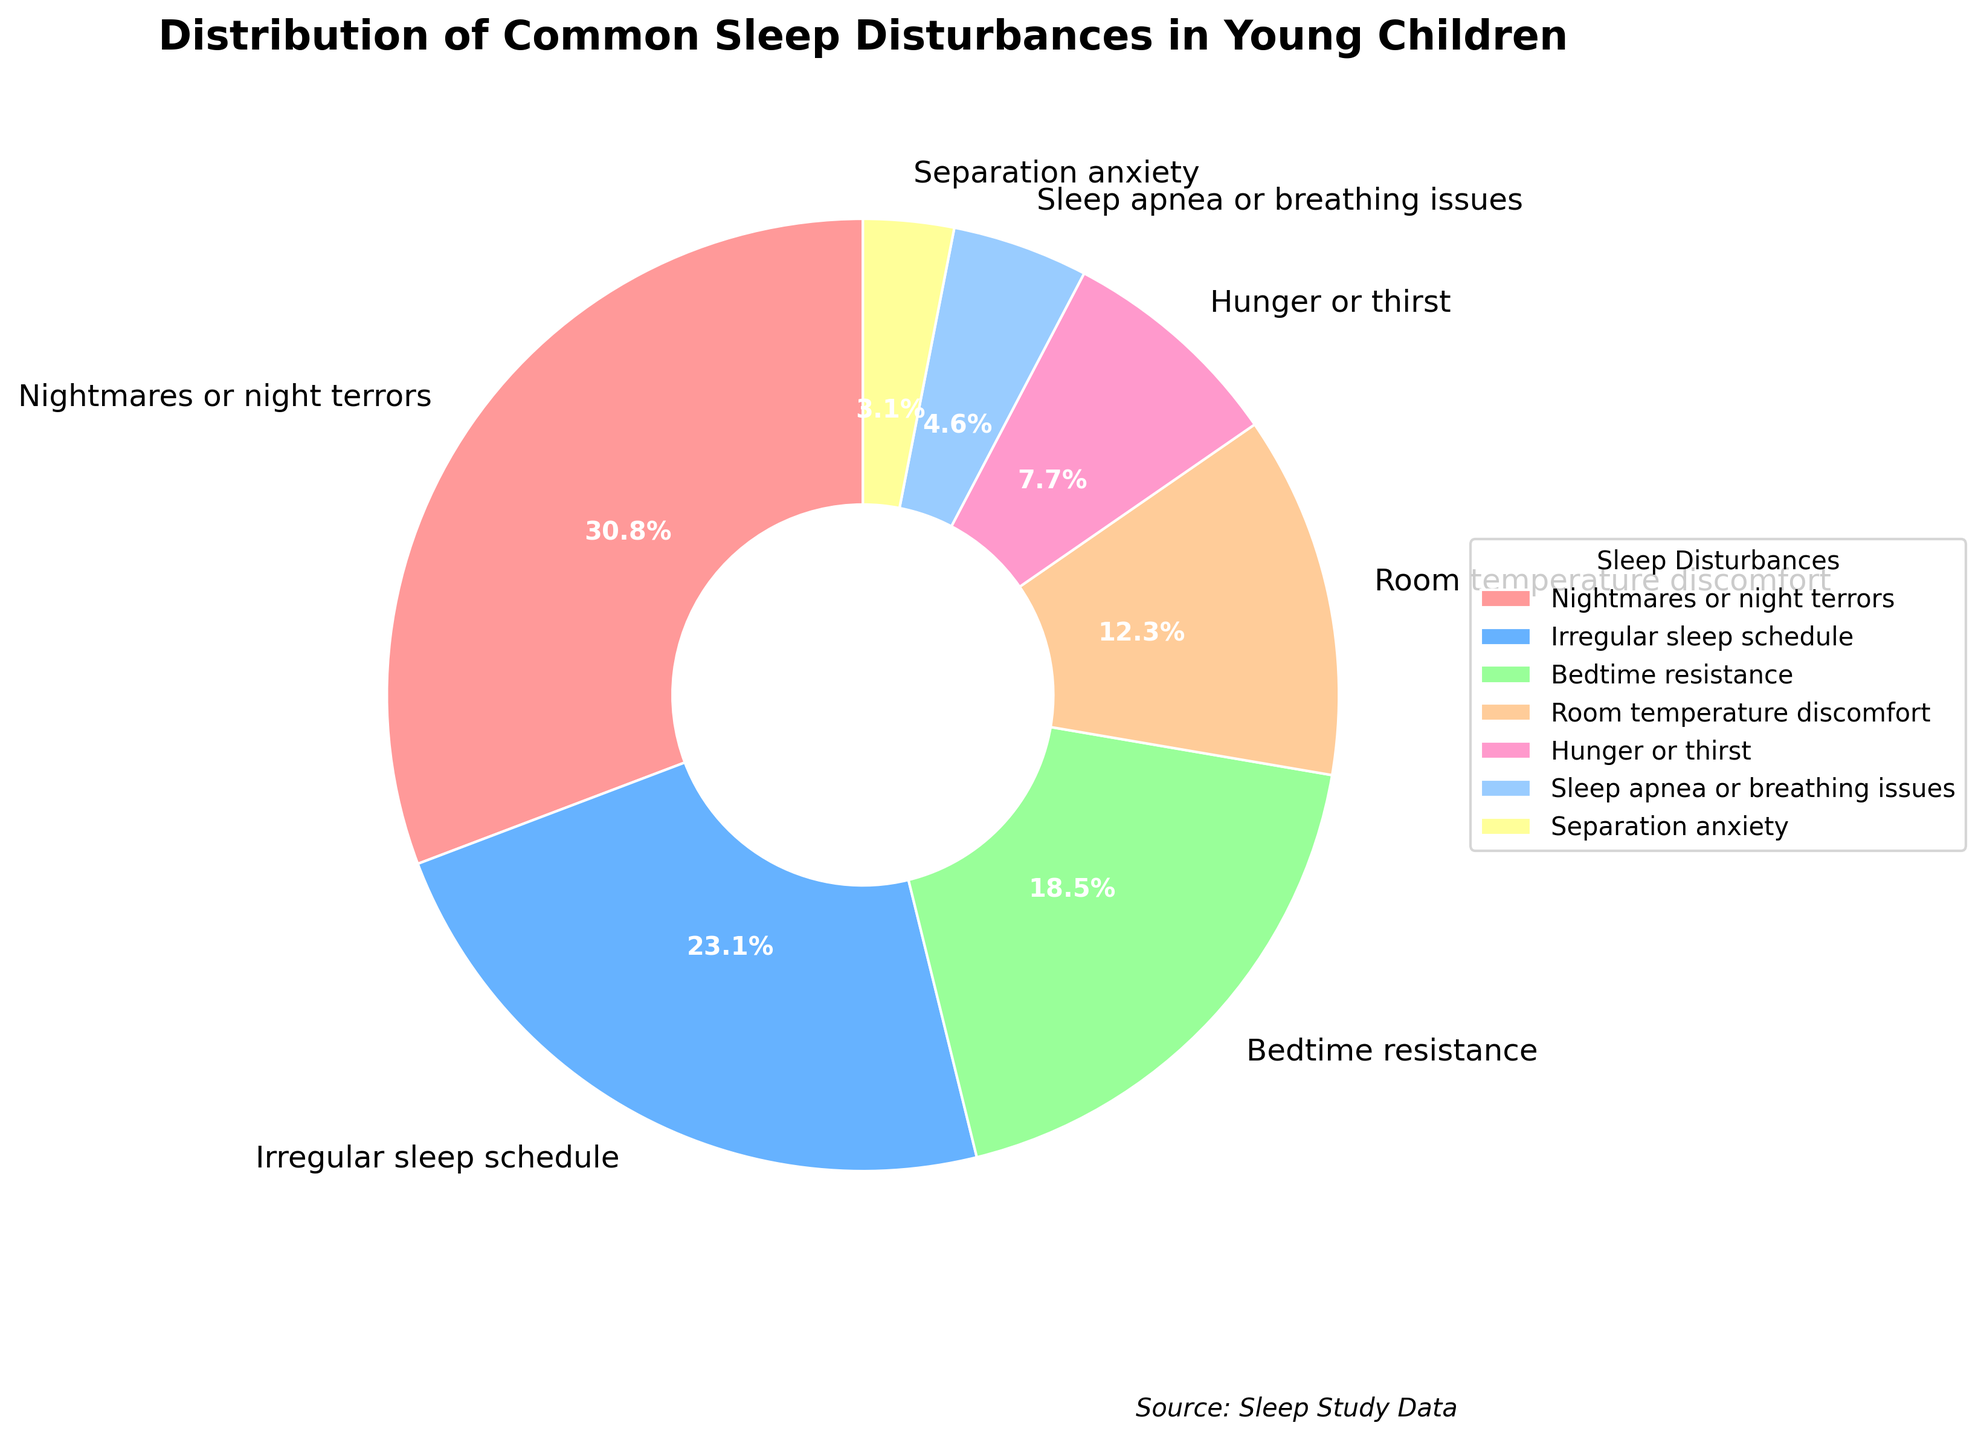Which sleep disturbance has the highest percentage? The category with the highest percentage segment in the pie chart is identified by finding the largest wedge. This category is "Nightmares or night terrors" with 20%.
Answer: Nightmares or night terrors What is the sum of the percentages for "Irregular sleep schedule" and "Bedtime resistance"? Identify the percentages for "Irregular sleep schedule" (15%) and "Bedtime resistance" (12%), then add them together: 15% + 12% = 27%.
Answer: 27% Which sleep disturbance has a lower percentage: "Room temperature discomfort" or "Hunger or thirst"? Compare the segment sizes for "Room temperature discomfort" (8%) and "Hunger or thirst" (5%). 5% is less than 8%.
Answer: Hunger or thirst What is the total percentage of sleep disturbances related to physical comfort issues such as "Room temperature discomfort" and "Hunger or thirst"? Identify the percentages for "Room temperature discomfort" (8%) and "Hunger or thirst" (5%), then add them together: 8% + 5% = 13%.
Answer: 13% How much greater is the percentage of "Nightmares or night terrors" compared to "Sleep apnea or breathing issues"? Find the difference between the percentages of "Nightmares or night terrors" (20%) and "Sleep apnea or breathing issues" (3%): 20% - 3% = 17%.
Answer: 17% What percentage of the total do "Separation anxiety" and "Sleep apnea or breathing issues" together represent? Add the percentages of "Separation anxiety" (2%) and "Sleep apnea or breathing issues" (3%): 2% + 3% = 5%.
Answer: 5% Which category represents the second highest percentage of sleep disturbances? The category with the second largest wedge, after "Nightmares or night terrors" (20%), is "Irregular sleep schedule" (15%).
Answer: Irregular sleep schedule Among all the categories, what is the average percentage of sleep disturbances? Add all percentages (20%, 15%, 12%, 8%, 5%, 3%, 2%) and divide by the number of categories (7): (20% + 15% + 12% + 8% + 5% + 3% + 2%) / 7 = 9.29% (rounded to two decimal places).
Answer: 9.29% 